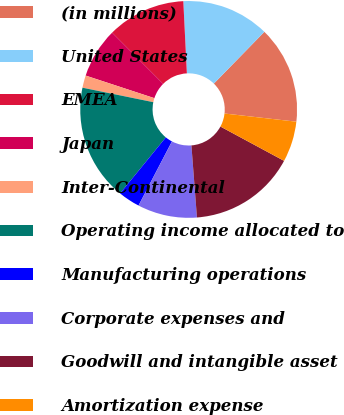Convert chart. <chart><loc_0><loc_0><loc_500><loc_500><pie_chart><fcel>(in millions)<fcel>United States<fcel>EMEA<fcel>Japan<fcel>Inter-Continental<fcel>Operating income allocated to<fcel>Manufacturing operations<fcel>Corporate expenses and<fcel>Goodwill and intangible asset<fcel>Amortization expense<nl><fcel>14.5%<fcel>13.09%<fcel>11.69%<fcel>7.47%<fcel>1.84%<fcel>17.31%<fcel>3.25%<fcel>8.87%<fcel>15.91%<fcel>6.06%<nl></chart> 